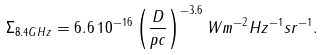Convert formula to latex. <formula><loc_0><loc_0><loc_500><loc_500>\Sigma _ { 8 . 4 G H z } = 6 . 6 \, 1 0 ^ { - 1 6 } \left ( \frac { D } { p c } \right ) ^ { - 3 . 6 } W m ^ { - 2 } H z ^ { - 1 } s r ^ { - 1 } .</formula> 